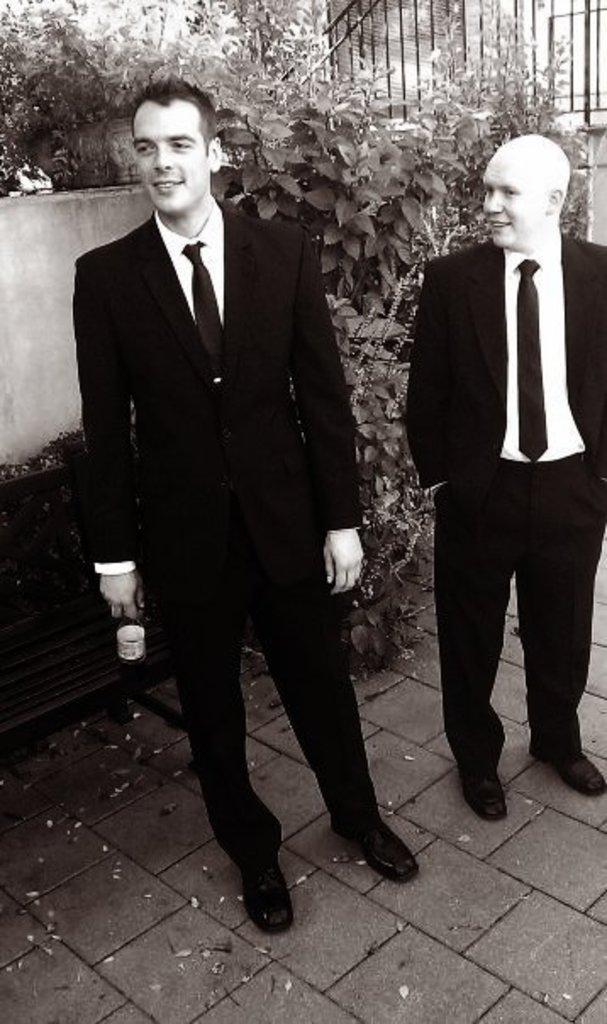Can you describe this image briefly? This is a black and white image which is clicked outside. In the center we can see the two persons wearing suits and standing on the ground. In the background we can see the plants and a wall and some other objects and a bench. 